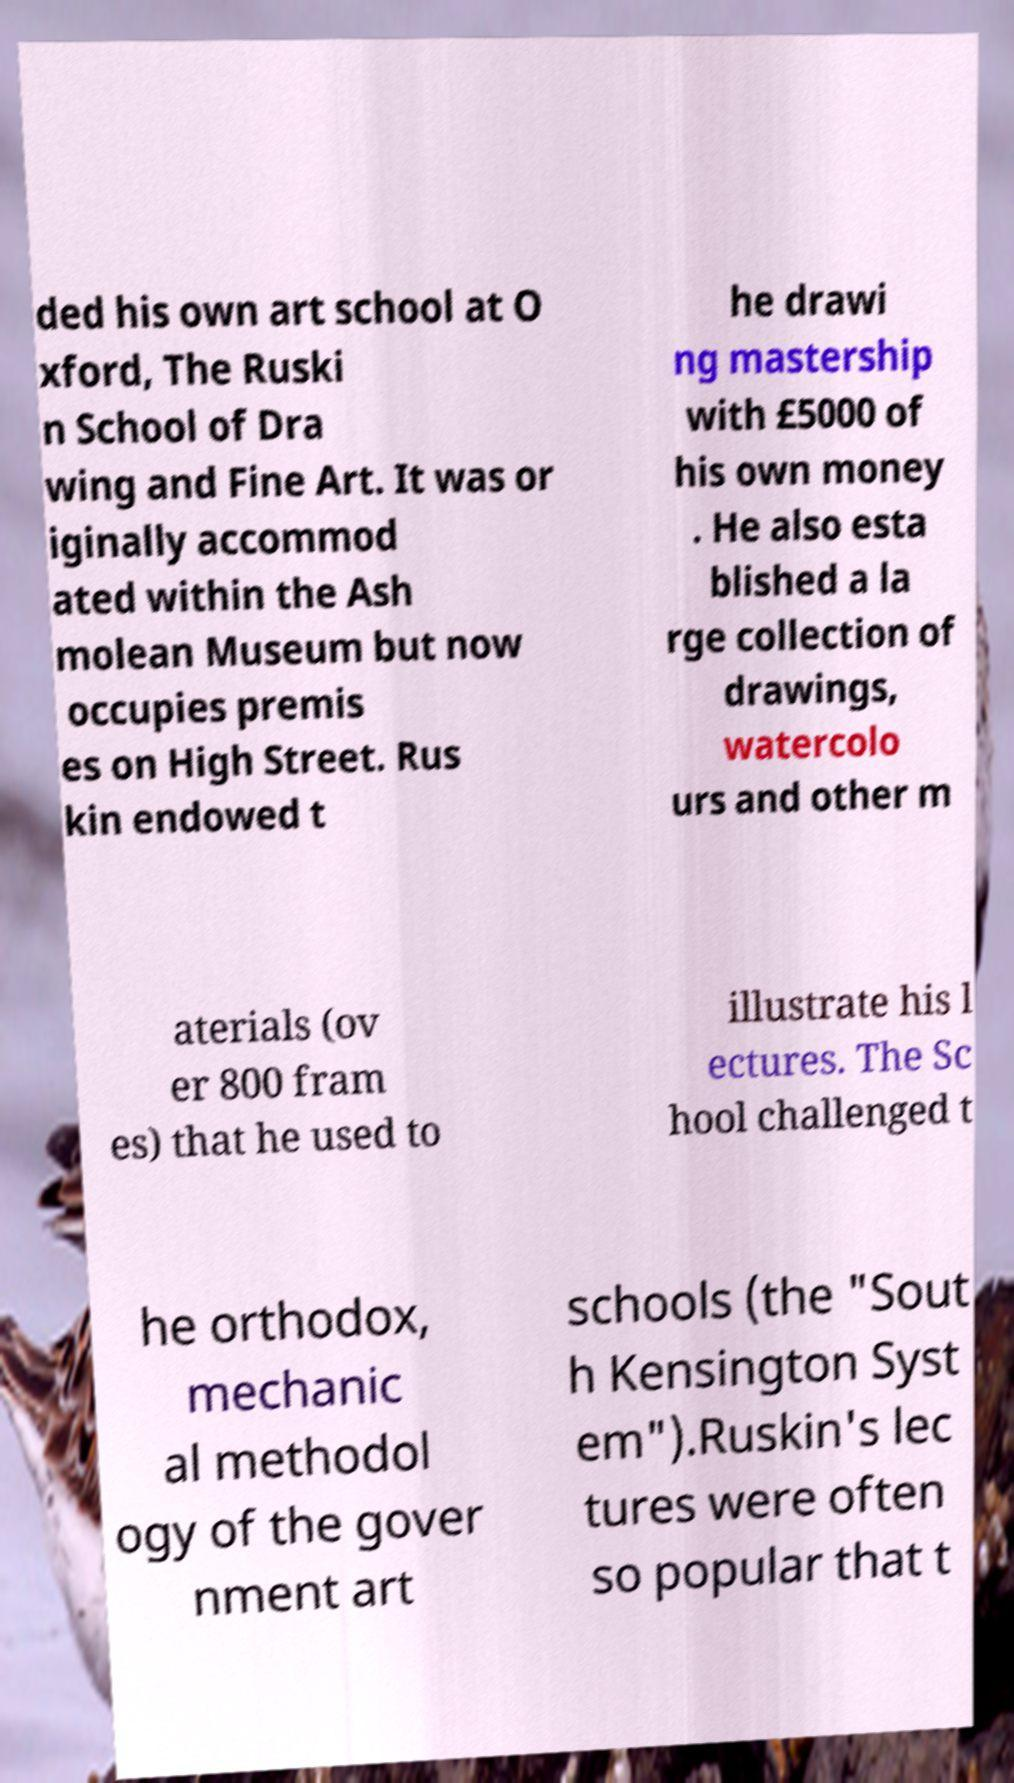Can you read and provide the text displayed in the image?This photo seems to have some interesting text. Can you extract and type it out for me? ded his own art school at O xford, The Ruski n School of Dra wing and Fine Art. It was or iginally accommod ated within the Ash molean Museum but now occupies premis es on High Street. Rus kin endowed t he drawi ng mastership with £5000 of his own money . He also esta blished a la rge collection of drawings, watercolo urs and other m aterials (ov er 800 fram es) that he used to illustrate his l ectures. The Sc hool challenged t he orthodox, mechanic al methodol ogy of the gover nment art schools (the "Sout h Kensington Syst em").Ruskin's lec tures were often so popular that t 